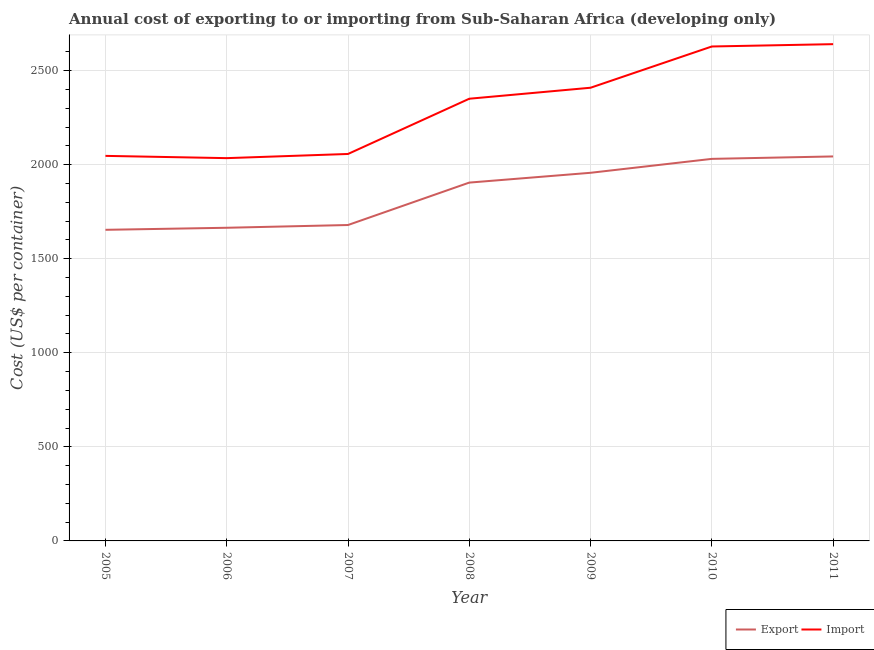How many different coloured lines are there?
Ensure brevity in your answer.  2. Does the line corresponding to import cost intersect with the line corresponding to export cost?
Your answer should be very brief. No. Is the number of lines equal to the number of legend labels?
Offer a very short reply. Yes. What is the export cost in 2009?
Offer a terse response. 1957. Across all years, what is the maximum import cost?
Your response must be concise. 2640.8. Across all years, what is the minimum export cost?
Make the answer very short. 1653.84. What is the total import cost in the graph?
Make the answer very short. 1.62e+04. What is the difference between the export cost in 2005 and that in 2011?
Offer a very short reply. -390.07. What is the difference between the import cost in 2006 and the export cost in 2005?
Provide a succinct answer. 381. What is the average export cost per year?
Your answer should be compact. 1847.82. In the year 2006, what is the difference between the export cost and import cost?
Your answer should be compact. -370.09. In how many years, is the export cost greater than 800 US$?
Give a very brief answer. 7. What is the ratio of the export cost in 2007 to that in 2009?
Keep it short and to the point. 0.86. Is the difference between the export cost in 2005 and 2008 greater than the difference between the import cost in 2005 and 2008?
Give a very brief answer. Yes. What is the difference between the highest and the second highest export cost?
Give a very brief answer. 12.91. What is the difference between the highest and the lowest import cost?
Your response must be concise. 605.95. Is the sum of the import cost in 2005 and 2008 greater than the maximum export cost across all years?
Your answer should be very brief. Yes. How many lines are there?
Offer a terse response. 2. Does the graph contain any zero values?
Your answer should be compact. No. Does the graph contain grids?
Offer a terse response. Yes. How many legend labels are there?
Make the answer very short. 2. What is the title of the graph?
Ensure brevity in your answer.  Annual cost of exporting to or importing from Sub-Saharan Africa (developing only). What is the label or title of the Y-axis?
Your answer should be very brief. Cost (US$ per container). What is the Cost (US$ per container) of Export in 2005?
Your answer should be very brief. 1653.84. What is the Cost (US$ per container) in Import in 2005?
Ensure brevity in your answer.  2046.91. What is the Cost (US$ per container) in Export in 2006?
Offer a very short reply. 1664.75. What is the Cost (US$ per container) of Import in 2006?
Keep it short and to the point. 2034.84. What is the Cost (US$ per container) of Export in 2007?
Provide a succinct answer. 1679.36. What is the Cost (US$ per container) in Import in 2007?
Provide a short and direct response. 2057.07. What is the Cost (US$ per container) of Export in 2008?
Ensure brevity in your answer.  1904.89. What is the Cost (US$ per container) in Import in 2008?
Provide a succinct answer. 2350.7. What is the Cost (US$ per container) of Export in 2009?
Your answer should be very brief. 1957. What is the Cost (US$ per container) of Import in 2009?
Provide a short and direct response. 2409.14. What is the Cost (US$ per container) of Export in 2010?
Provide a succinct answer. 2031. What is the Cost (US$ per container) in Import in 2010?
Offer a very short reply. 2628.43. What is the Cost (US$ per container) of Export in 2011?
Give a very brief answer. 2043.91. What is the Cost (US$ per container) in Import in 2011?
Offer a very short reply. 2640.8. Across all years, what is the maximum Cost (US$ per container) of Export?
Give a very brief answer. 2043.91. Across all years, what is the maximum Cost (US$ per container) of Import?
Your response must be concise. 2640.8. Across all years, what is the minimum Cost (US$ per container) in Export?
Your answer should be compact. 1653.84. Across all years, what is the minimum Cost (US$ per container) in Import?
Offer a terse response. 2034.84. What is the total Cost (US$ per container) in Export in the graph?
Provide a short and direct response. 1.29e+04. What is the total Cost (US$ per container) in Import in the graph?
Provide a succinct answer. 1.62e+04. What is the difference between the Cost (US$ per container) of Export in 2005 and that in 2006?
Make the answer very short. -10.91. What is the difference between the Cost (US$ per container) in Import in 2005 and that in 2006?
Your response must be concise. 12.07. What is the difference between the Cost (US$ per container) of Export in 2005 and that in 2007?
Provide a succinct answer. -25.53. What is the difference between the Cost (US$ per container) in Import in 2005 and that in 2007?
Your answer should be compact. -10.16. What is the difference between the Cost (US$ per container) in Export in 2005 and that in 2008?
Keep it short and to the point. -251.05. What is the difference between the Cost (US$ per container) of Import in 2005 and that in 2008?
Your answer should be compact. -303.8. What is the difference between the Cost (US$ per container) of Export in 2005 and that in 2009?
Give a very brief answer. -303.16. What is the difference between the Cost (US$ per container) in Import in 2005 and that in 2009?
Give a very brief answer. -362.23. What is the difference between the Cost (US$ per container) of Export in 2005 and that in 2010?
Provide a short and direct response. -377.16. What is the difference between the Cost (US$ per container) of Import in 2005 and that in 2010?
Ensure brevity in your answer.  -581.52. What is the difference between the Cost (US$ per container) in Export in 2005 and that in 2011?
Keep it short and to the point. -390.07. What is the difference between the Cost (US$ per container) in Import in 2005 and that in 2011?
Provide a short and direct response. -593.89. What is the difference between the Cost (US$ per container) of Export in 2006 and that in 2007?
Give a very brief answer. -14.61. What is the difference between the Cost (US$ per container) of Import in 2006 and that in 2007?
Your response must be concise. -22.23. What is the difference between the Cost (US$ per container) of Export in 2006 and that in 2008?
Your answer should be compact. -240.14. What is the difference between the Cost (US$ per container) in Import in 2006 and that in 2008?
Offer a very short reply. -315.86. What is the difference between the Cost (US$ per container) of Export in 2006 and that in 2009?
Make the answer very short. -292.25. What is the difference between the Cost (US$ per container) of Import in 2006 and that in 2009?
Give a very brief answer. -374.3. What is the difference between the Cost (US$ per container) of Export in 2006 and that in 2010?
Ensure brevity in your answer.  -366.25. What is the difference between the Cost (US$ per container) in Import in 2006 and that in 2010?
Offer a terse response. -593.59. What is the difference between the Cost (US$ per container) of Export in 2006 and that in 2011?
Offer a very short reply. -379.16. What is the difference between the Cost (US$ per container) in Import in 2006 and that in 2011?
Your answer should be compact. -605.95. What is the difference between the Cost (US$ per container) of Export in 2007 and that in 2008?
Keep it short and to the point. -225.52. What is the difference between the Cost (US$ per container) of Import in 2007 and that in 2008?
Provide a short and direct response. -293.64. What is the difference between the Cost (US$ per container) in Export in 2007 and that in 2009?
Your response must be concise. -277.64. What is the difference between the Cost (US$ per container) of Import in 2007 and that in 2009?
Keep it short and to the point. -352.07. What is the difference between the Cost (US$ per container) in Export in 2007 and that in 2010?
Make the answer very short. -351.64. What is the difference between the Cost (US$ per container) in Import in 2007 and that in 2010?
Your answer should be very brief. -571.36. What is the difference between the Cost (US$ per container) of Export in 2007 and that in 2011?
Your answer should be compact. -364.55. What is the difference between the Cost (US$ per container) in Import in 2007 and that in 2011?
Make the answer very short. -583.73. What is the difference between the Cost (US$ per container) of Export in 2008 and that in 2009?
Ensure brevity in your answer.  -52.11. What is the difference between the Cost (US$ per container) of Import in 2008 and that in 2009?
Keep it short and to the point. -58.43. What is the difference between the Cost (US$ per container) of Export in 2008 and that in 2010?
Keep it short and to the point. -126.11. What is the difference between the Cost (US$ per container) of Import in 2008 and that in 2010?
Make the answer very short. -277.73. What is the difference between the Cost (US$ per container) in Export in 2008 and that in 2011?
Make the answer very short. -139.02. What is the difference between the Cost (US$ per container) in Import in 2008 and that in 2011?
Give a very brief answer. -290.09. What is the difference between the Cost (US$ per container) in Export in 2009 and that in 2010?
Your response must be concise. -74. What is the difference between the Cost (US$ per container) of Import in 2009 and that in 2010?
Provide a short and direct response. -219.3. What is the difference between the Cost (US$ per container) of Export in 2009 and that in 2011?
Provide a short and direct response. -86.91. What is the difference between the Cost (US$ per container) of Import in 2009 and that in 2011?
Keep it short and to the point. -231.66. What is the difference between the Cost (US$ per container) of Export in 2010 and that in 2011?
Provide a short and direct response. -12.91. What is the difference between the Cost (US$ per container) of Import in 2010 and that in 2011?
Give a very brief answer. -12.36. What is the difference between the Cost (US$ per container) of Export in 2005 and the Cost (US$ per container) of Import in 2006?
Make the answer very short. -381. What is the difference between the Cost (US$ per container) in Export in 2005 and the Cost (US$ per container) in Import in 2007?
Offer a terse response. -403.23. What is the difference between the Cost (US$ per container) of Export in 2005 and the Cost (US$ per container) of Import in 2008?
Offer a very short reply. -696.87. What is the difference between the Cost (US$ per container) of Export in 2005 and the Cost (US$ per container) of Import in 2009?
Give a very brief answer. -755.3. What is the difference between the Cost (US$ per container) of Export in 2005 and the Cost (US$ per container) of Import in 2010?
Offer a terse response. -974.59. What is the difference between the Cost (US$ per container) in Export in 2005 and the Cost (US$ per container) in Import in 2011?
Provide a succinct answer. -986.96. What is the difference between the Cost (US$ per container) in Export in 2006 and the Cost (US$ per container) in Import in 2007?
Give a very brief answer. -392.32. What is the difference between the Cost (US$ per container) of Export in 2006 and the Cost (US$ per container) of Import in 2008?
Offer a terse response. -685.95. What is the difference between the Cost (US$ per container) of Export in 2006 and the Cost (US$ per container) of Import in 2009?
Make the answer very short. -744.39. What is the difference between the Cost (US$ per container) of Export in 2006 and the Cost (US$ per container) of Import in 2010?
Offer a very short reply. -963.68. What is the difference between the Cost (US$ per container) in Export in 2006 and the Cost (US$ per container) in Import in 2011?
Provide a succinct answer. -976.05. What is the difference between the Cost (US$ per container) in Export in 2007 and the Cost (US$ per container) in Import in 2008?
Offer a very short reply. -671.34. What is the difference between the Cost (US$ per container) in Export in 2007 and the Cost (US$ per container) in Import in 2009?
Offer a terse response. -729.77. What is the difference between the Cost (US$ per container) of Export in 2007 and the Cost (US$ per container) of Import in 2010?
Your response must be concise. -949.07. What is the difference between the Cost (US$ per container) in Export in 2007 and the Cost (US$ per container) in Import in 2011?
Offer a terse response. -961.43. What is the difference between the Cost (US$ per container) of Export in 2008 and the Cost (US$ per container) of Import in 2009?
Your answer should be very brief. -504.25. What is the difference between the Cost (US$ per container) in Export in 2008 and the Cost (US$ per container) in Import in 2010?
Offer a terse response. -723.55. What is the difference between the Cost (US$ per container) in Export in 2008 and the Cost (US$ per container) in Import in 2011?
Give a very brief answer. -735.91. What is the difference between the Cost (US$ per container) of Export in 2009 and the Cost (US$ per container) of Import in 2010?
Ensure brevity in your answer.  -671.43. What is the difference between the Cost (US$ per container) of Export in 2009 and the Cost (US$ per container) of Import in 2011?
Offer a terse response. -683.8. What is the difference between the Cost (US$ per container) of Export in 2010 and the Cost (US$ per container) of Import in 2011?
Provide a short and direct response. -609.8. What is the average Cost (US$ per container) of Export per year?
Provide a short and direct response. 1847.82. What is the average Cost (US$ per container) in Import per year?
Your answer should be compact. 2309.7. In the year 2005, what is the difference between the Cost (US$ per container) in Export and Cost (US$ per container) in Import?
Give a very brief answer. -393.07. In the year 2006, what is the difference between the Cost (US$ per container) of Export and Cost (US$ per container) of Import?
Your answer should be compact. -370.09. In the year 2007, what is the difference between the Cost (US$ per container) in Export and Cost (US$ per container) in Import?
Your answer should be compact. -377.7. In the year 2008, what is the difference between the Cost (US$ per container) of Export and Cost (US$ per container) of Import?
Provide a succinct answer. -445.82. In the year 2009, what is the difference between the Cost (US$ per container) of Export and Cost (US$ per container) of Import?
Provide a succinct answer. -452.14. In the year 2010, what is the difference between the Cost (US$ per container) in Export and Cost (US$ per container) in Import?
Your answer should be compact. -597.43. In the year 2011, what is the difference between the Cost (US$ per container) of Export and Cost (US$ per container) of Import?
Ensure brevity in your answer.  -596.89. What is the ratio of the Cost (US$ per container) of Import in 2005 to that in 2006?
Provide a succinct answer. 1.01. What is the ratio of the Cost (US$ per container) of Export in 2005 to that in 2008?
Ensure brevity in your answer.  0.87. What is the ratio of the Cost (US$ per container) in Import in 2005 to that in 2008?
Make the answer very short. 0.87. What is the ratio of the Cost (US$ per container) of Export in 2005 to that in 2009?
Your response must be concise. 0.85. What is the ratio of the Cost (US$ per container) of Import in 2005 to that in 2009?
Make the answer very short. 0.85. What is the ratio of the Cost (US$ per container) in Export in 2005 to that in 2010?
Offer a very short reply. 0.81. What is the ratio of the Cost (US$ per container) of Import in 2005 to that in 2010?
Ensure brevity in your answer.  0.78. What is the ratio of the Cost (US$ per container) in Export in 2005 to that in 2011?
Your answer should be very brief. 0.81. What is the ratio of the Cost (US$ per container) of Import in 2005 to that in 2011?
Make the answer very short. 0.78. What is the ratio of the Cost (US$ per container) in Import in 2006 to that in 2007?
Your answer should be very brief. 0.99. What is the ratio of the Cost (US$ per container) of Export in 2006 to that in 2008?
Your answer should be compact. 0.87. What is the ratio of the Cost (US$ per container) in Import in 2006 to that in 2008?
Provide a short and direct response. 0.87. What is the ratio of the Cost (US$ per container) of Export in 2006 to that in 2009?
Your response must be concise. 0.85. What is the ratio of the Cost (US$ per container) in Import in 2006 to that in 2009?
Ensure brevity in your answer.  0.84. What is the ratio of the Cost (US$ per container) of Export in 2006 to that in 2010?
Offer a terse response. 0.82. What is the ratio of the Cost (US$ per container) of Import in 2006 to that in 2010?
Keep it short and to the point. 0.77. What is the ratio of the Cost (US$ per container) in Export in 2006 to that in 2011?
Offer a very short reply. 0.81. What is the ratio of the Cost (US$ per container) in Import in 2006 to that in 2011?
Ensure brevity in your answer.  0.77. What is the ratio of the Cost (US$ per container) in Export in 2007 to that in 2008?
Make the answer very short. 0.88. What is the ratio of the Cost (US$ per container) of Import in 2007 to that in 2008?
Provide a succinct answer. 0.88. What is the ratio of the Cost (US$ per container) of Export in 2007 to that in 2009?
Ensure brevity in your answer.  0.86. What is the ratio of the Cost (US$ per container) of Import in 2007 to that in 2009?
Keep it short and to the point. 0.85. What is the ratio of the Cost (US$ per container) in Export in 2007 to that in 2010?
Your answer should be very brief. 0.83. What is the ratio of the Cost (US$ per container) of Import in 2007 to that in 2010?
Offer a terse response. 0.78. What is the ratio of the Cost (US$ per container) in Export in 2007 to that in 2011?
Offer a very short reply. 0.82. What is the ratio of the Cost (US$ per container) in Import in 2007 to that in 2011?
Keep it short and to the point. 0.78. What is the ratio of the Cost (US$ per container) of Export in 2008 to that in 2009?
Offer a very short reply. 0.97. What is the ratio of the Cost (US$ per container) in Import in 2008 to that in 2009?
Provide a short and direct response. 0.98. What is the ratio of the Cost (US$ per container) in Export in 2008 to that in 2010?
Offer a very short reply. 0.94. What is the ratio of the Cost (US$ per container) in Import in 2008 to that in 2010?
Give a very brief answer. 0.89. What is the ratio of the Cost (US$ per container) of Export in 2008 to that in 2011?
Your answer should be very brief. 0.93. What is the ratio of the Cost (US$ per container) in Import in 2008 to that in 2011?
Your answer should be compact. 0.89. What is the ratio of the Cost (US$ per container) of Export in 2009 to that in 2010?
Provide a succinct answer. 0.96. What is the ratio of the Cost (US$ per container) of Import in 2009 to that in 2010?
Offer a terse response. 0.92. What is the ratio of the Cost (US$ per container) of Export in 2009 to that in 2011?
Your answer should be very brief. 0.96. What is the ratio of the Cost (US$ per container) of Import in 2009 to that in 2011?
Ensure brevity in your answer.  0.91. What is the ratio of the Cost (US$ per container) in Import in 2010 to that in 2011?
Your response must be concise. 1. What is the difference between the highest and the second highest Cost (US$ per container) in Export?
Ensure brevity in your answer.  12.91. What is the difference between the highest and the second highest Cost (US$ per container) of Import?
Keep it short and to the point. 12.36. What is the difference between the highest and the lowest Cost (US$ per container) in Export?
Your answer should be very brief. 390.07. What is the difference between the highest and the lowest Cost (US$ per container) of Import?
Provide a succinct answer. 605.95. 